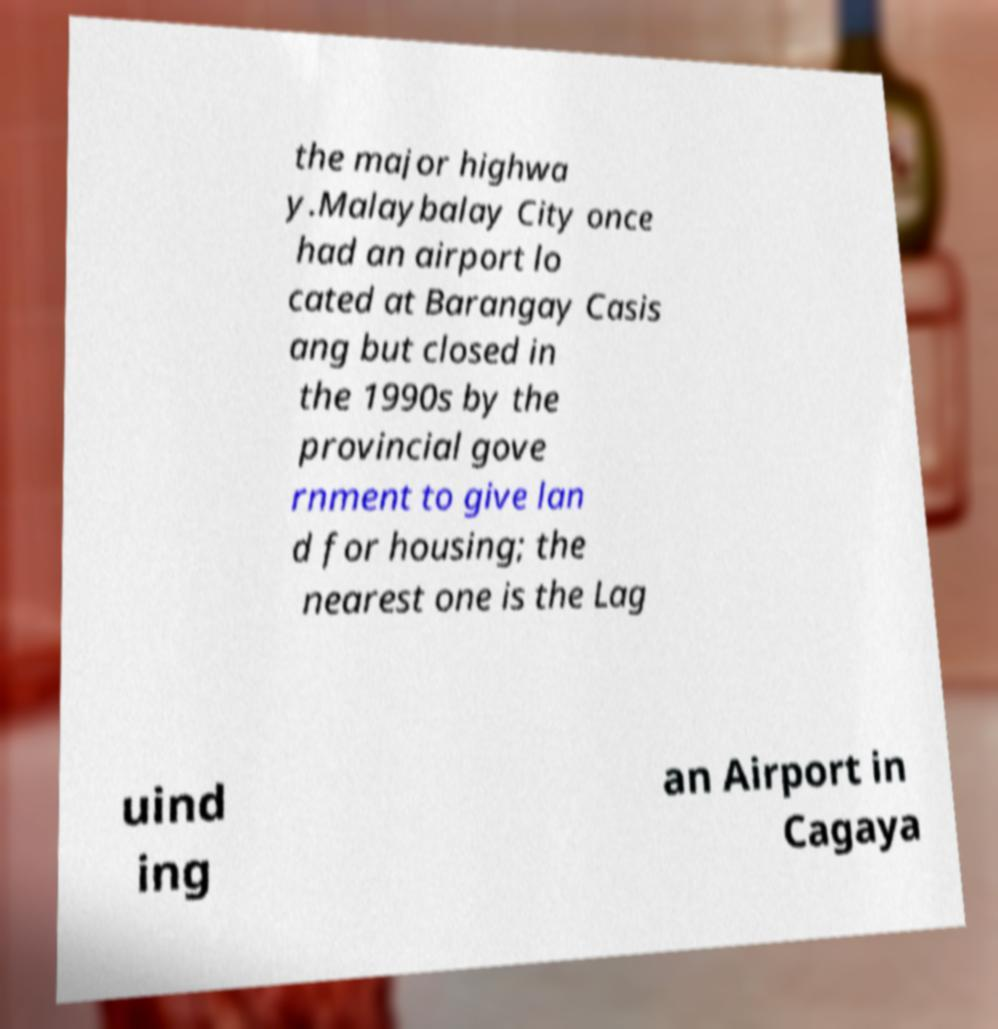There's text embedded in this image that I need extracted. Can you transcribe it verbatim? the major highwa y.Malaybalay City once had an airport lo cated at Barangay Casis ang but closed in the 1990s by the provincial gove rnment to give lan d for housing; the nearest one is the Lag uind ing an Airport in Cagaya 